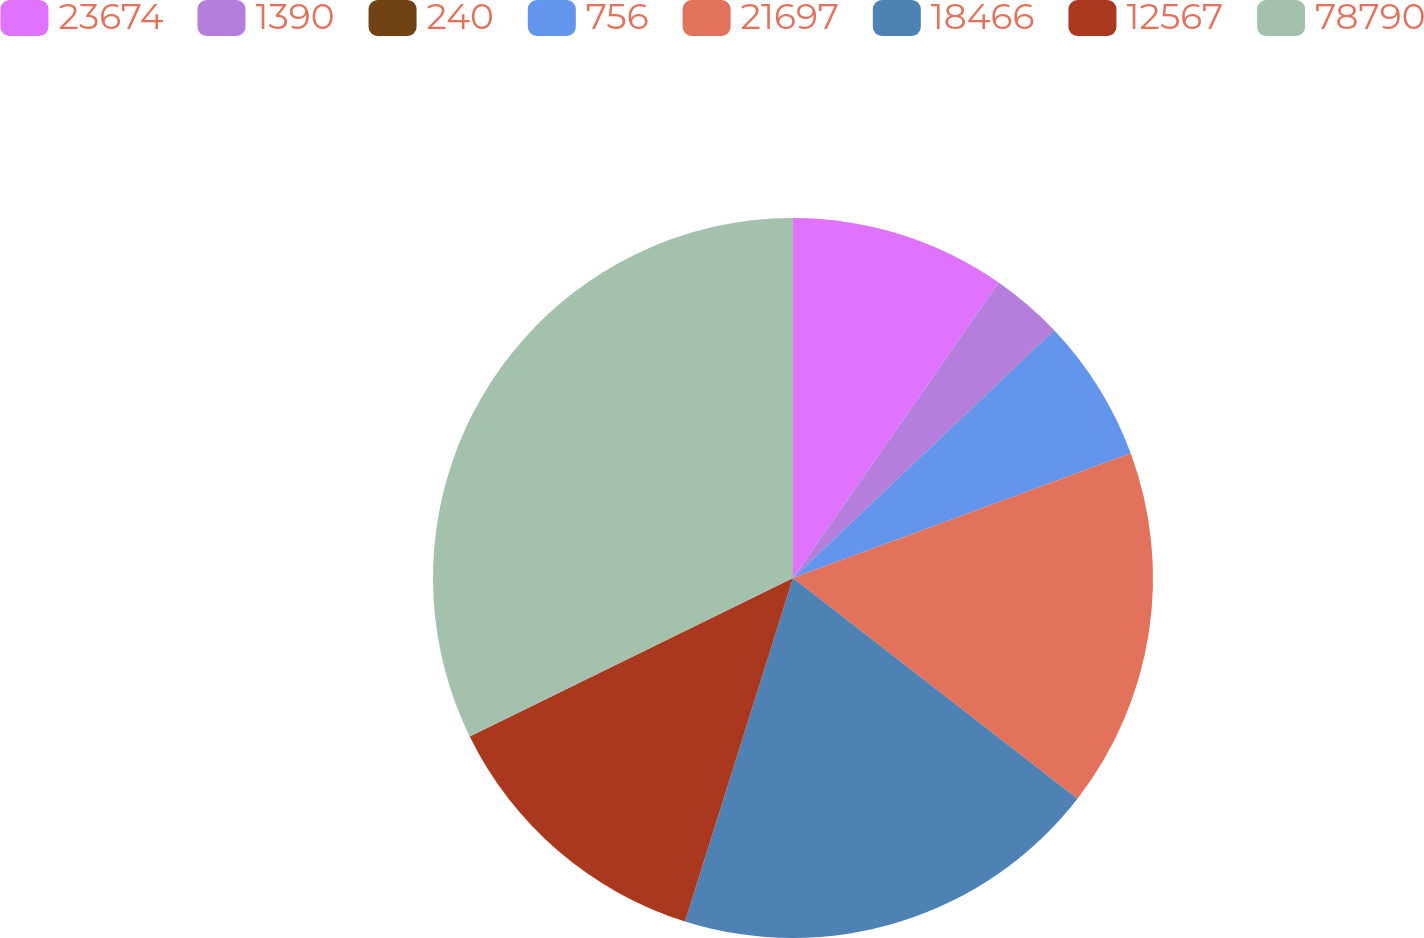Convert chart. <chart><loc_0><loc_0><loc_500><loc_500><pie_chart><fcel>23674<fcel>1390<fcel>240<fcel>756<fcel>21697<fcel>18466<fcel>12567<fcel>78790<nl><fcel>9.68%<fcel>3.23%<fcel>0.01%<fcel>6.45%<fcel>16.13%<fcel>19.35%<fcel>12.9%<fcel>32.25%<nl></chart> 